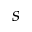Convert formula to latex. <formula><loc_0><loc_0><loc_500><loc_500>s</formula> 